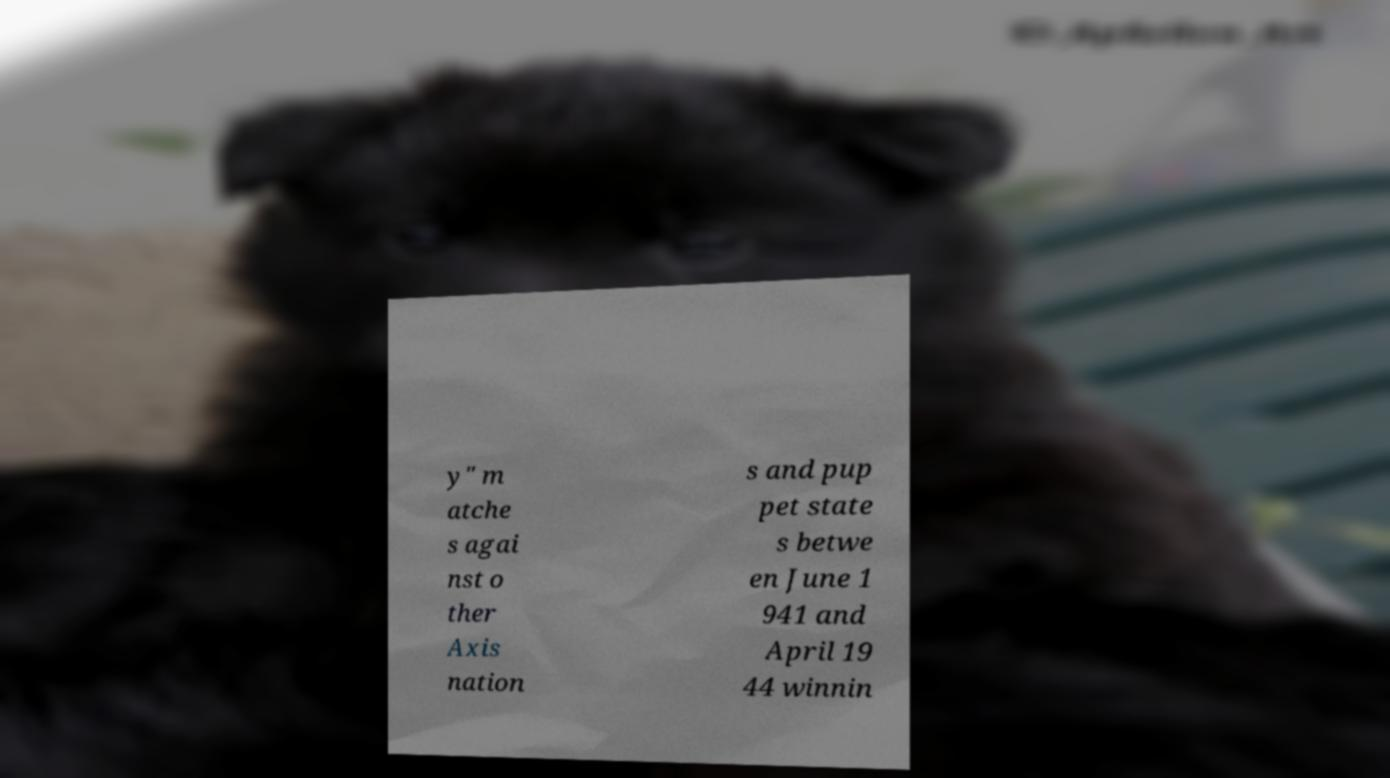Can you read and provide the text displayed in the image?This photo seems to have some interesting text. Can you extract and type it out for me? y" m atche s agai nst o ther Axis nation s and pup pet state s betwe en June 1 941 and April 19 44 winnin 